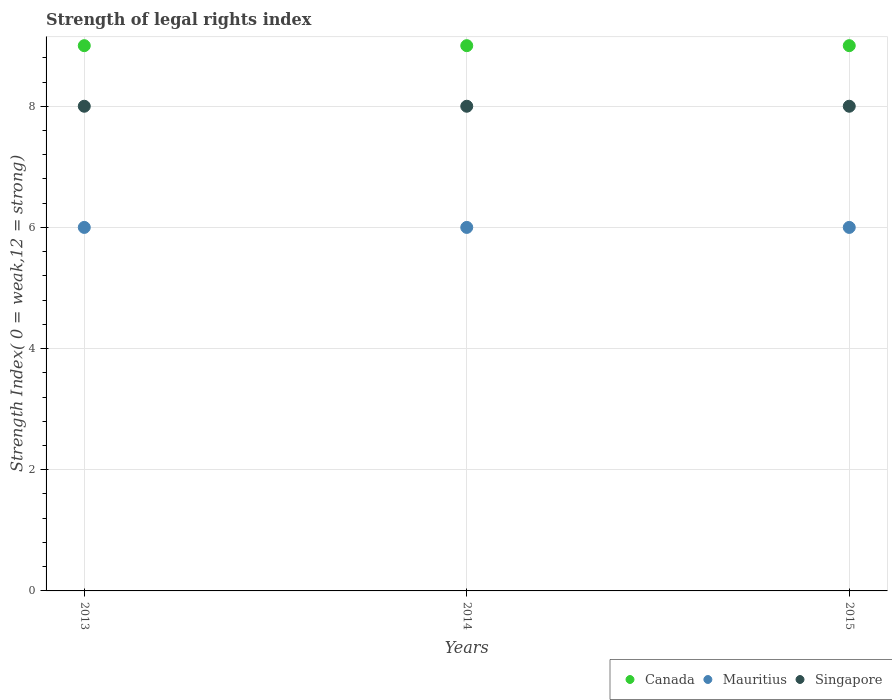Is the number of dotlines equal to the number of legend labels?
Provide a succinct answer. Yes. What is the strength index in Canada in 2014?
Make the answer very short. 9. Across all years, what is the maximum strength index in Singapore?
Offer a very short reply. 8. Across all years, what is the minimum strength index in Singapore?
Offer a terse response. 8. In which year was the strength index in Canada minimum?
Offer a terse response. 2013. What is the total strength index in Canada in the graph?
Provide a succinct answer. 27. What is the difference between the strength index in Mauritius in 2013 and that in 2015?
Make the answer very short. 0. What is the difference between the strength index in Canada in 2015 and the strength index in Mauritius in 2013?
Ensure brevity in your answer.  3. What is the average strength index in Mauritius per year?
Provide a short and direct response. 6. In the year 2014, what is the difference between the strength index in Singapore and strength index in Mauritius?
Provide a short and direct response. 2. In how many years, is the strength index in Singapore greater than 0.4?
Your response must be concise. 3. Is the strength index in Canada in 2013 less than that in 2015?
Provide a short and direct response. No. What is the difference between the highest and the second highest strength index in Mauritius?
Offer a terse response. 0. In how many years, is the strength index in Canada greater than the average strength index in Canada taken over all years?
Ensure brevity in your answer.  0. Is the sum of the strength index in Canada in 2013 and 2014 greater than the maximum strength index in Singapore across all years?
Provide a short and direct response. Yes. Does the strength index in Singapore monotonically increase over the years?
Your answer should be compact. No. Is the strength index in Mauritius strictly less than the strength index in Canada over the years?
Make the answer very short. Yes. How many years are there in the graph?
Your answer should be compact. 3. Are the values on the major ticks of Y-axis written in scientific E-notation?
Give a very brief answer. No. Does the graph contain grids?
Offer a terse response. Yes. How many legend labels are there?
Keep it short and to the point. 3. How are the legend labels stacked?
Keep it short and to the point. Horizontal. What is the title of the graph?
Give a very brief answer. Strength of legal rights index. What is the label or title of the Y-axis?
Ensure brevity in your answer.  Strength Index( 0 = weak,12 = strong). What is the Strength Index( 0 = weak,12 = strong) in Singapore in 2013?
Your answer should be very brief. 8. What is the Strength Index( 0 = weak,12 = strong) of Canada in 2014?
Keep it short and to the point. 9. What is the Strength Index( 0 = weak,12 = strong) in Singapore in 2014?
Provide a succinct answer. 8. What is the Strength Index( 0 = weak,12 = strong) of Singapore in 2015?
Your answer should be very brief. 8. Across all years, what is the maximum Strength Index( 0 = weak,12 = strong) of Singapore?
Your response must be concise. 8. Across all years, what is the minimum Strength Index( 0 = weak,12 = strong) of Canada?
Your answer should be very brief. 9. What is the total Strength Index( 0 = weak,12 = strong) in Singapore in the graph?
Provide a short and direct response. 24. What is the difference between the Strength Index( 0 = weak,12 = strong) in Canada in 2013 and that in 2014?
Give a very brief answer. 0. What is the difference between the Strength Index( 0 = weak,12 = strong) in Canada in 2013 and that in 2015?
Make the answer very short. 0. What is the difference between the Strength Index( 0 = weak,12 = strong) of Mauritius in 2013 and that in 2015?
Your answer should be compact. 0. What is the difference between the Strength Index( 0 = weak,12 = strong) of Canada in 2014 and that in 2015?
Provide a succinct answer. 0. What is the difference between the Strength Index( 0 = weak,12 = strong) in Mauritius in 2014 and that in 2015?
Your answer should be very brief. 0. What is the difference between the Strength Index( 0 = weak,12 = strong) in Canada in 2013 and the Strength Index( 0 = weak,12 = strong) in Mauritius in 2014?
Offer a terse response. 3. What is the difference between the Strength Index( 0 = weak,12 = strong) of Mauritius in 2013 and the Strength Index( 0 = weak,12 = strong) of Singapore in 2014?
Your response must be concise. -2. What is the difference between the Strength Index( 0 = weak,12 = strong) in Canada in 2013 and the Strength Index( 0 = weak,12 = strong) in Mauritius in 2015?
Offer a terse response. 3. What is the difference between the Strength Index( 0 = weak,12 = strong) in Canada in 2013 and the Strength Index( 0 = weak,12 = strong) in Singapore in 2015?
Offer a terse response. 1. What is the difference between the Strength Index( 0 = weak,12 = strong) in Mauritius in 2013 and the Strength Index( 0 = weak,12 = strong) in Singapore in 2015?
Offer a terse response. -2. What is the difference between the Strength Index( 0 = weak,12 = strong) in Canada in 2014 and the Strength Index( 0 = weak,12 = strong) in Mauritius in 2015?
Make the answer very short. 3. What is the difference between the Strength Index( 0 = weak,12 = strong) in Canada in 2014 and the Strength Index( 0 = weak,12 = strong) in Singapore in 2015?
Provide a short and direct response. 1. What is the average Strength Index( 0 = weak,12 = strong) of Canada per year?
Offer a terse response. 9. In the year 2013, what is the difference between the Strength Index( 0 = weak,12 = strong) in Canada and Strength Index( 0 = weak,12 = strong) in Mauritius?
Your response must be concise. 3. In the year 2013, what is the difference between the Strength Index( 0 = weak,12 = strong) in Mauritius and Strength Index( 0 = weak,12 = strong) in Singapore?
Make the answer very short. -2. In the year 2015, what is the difference between the Strength Index( 0 = weak,12 = strong) in Canada and Strength Index( 0 = weak,12 = strong) in Mauritius?
Ensure brevity in your answer.  3. What is the ratio of the Strength Index( 0 = weak,12 = strong) of Canada in 2013 to that in 2014?
Provide a succinct answer. 1. What is the ratio of the Strength Index( 0 = weak,12 = strong) in Mauritius in 2013 to that in 2015?
Your response must be concise. 1. What is the ratio of the Strength Index( 0 = weak,12 = strong) of Mauritius in 2014 to that in 2015?
Your response must be concise. 1. What is the ratio of the Strength Index( 0 = weak,12 = strong) of Singapore in 2014 to that in 2015?
Your answer should be compact. 1. What is the difference between the highest and the second highest Strength Index( 0 = weak,12 = strong) in Canada?
Your answer should be compact. 0. What is the difference between the highest and the second highest Strength Index( 0 = weak,12 = strong) of Singapore?
Provide a succinct answer. 0. What is the difference between the highest and the lowest Strength Index( 0 = weak,12 = strong) of Mauritius?
Make the answer very short. 0. What is the difference between the highest and the lowest Strength Index( 0 = weak,12 = strong) of Singapore?
Give a very brief answer. 0. 